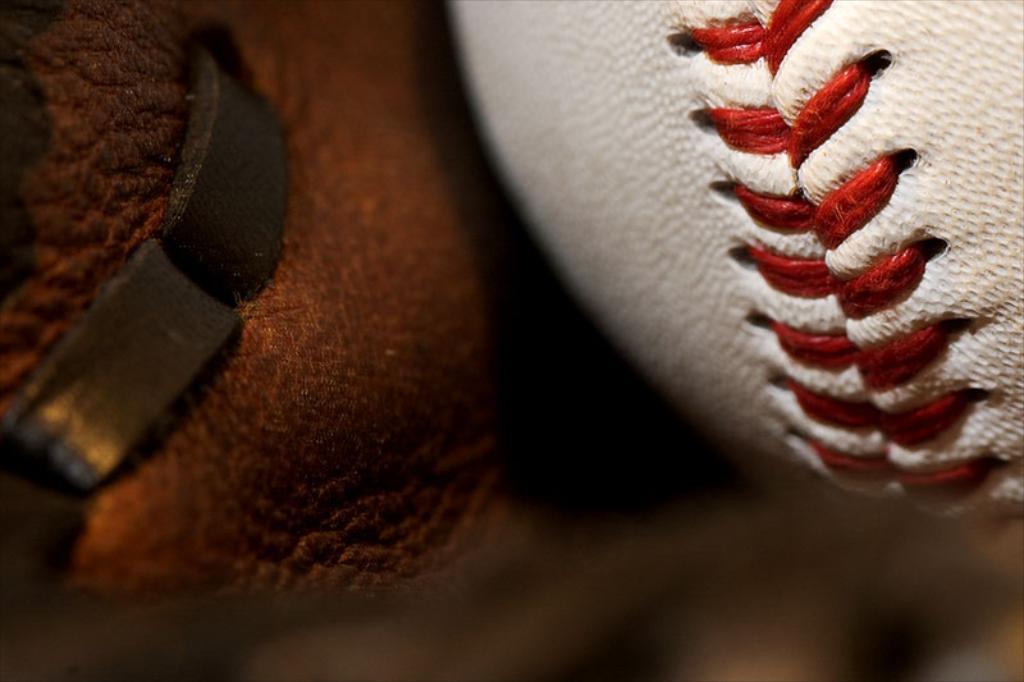Describe this image in one or two sentences. In this image we can see a rugby ball. On the left there is an object which is unclear. 